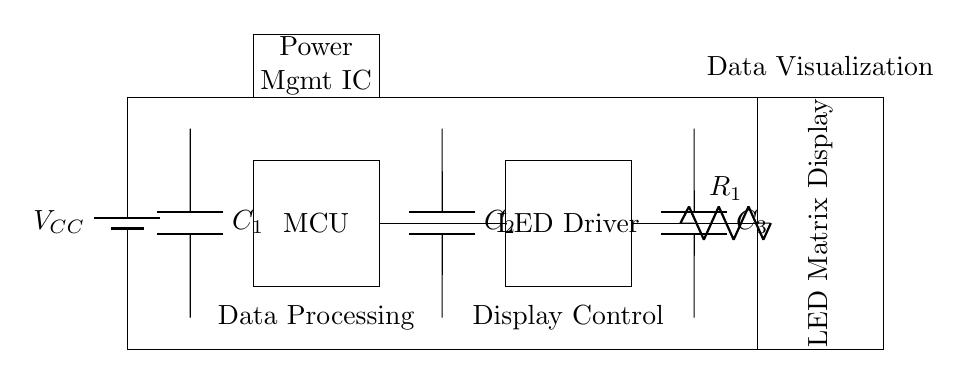What is the power supply component in this circuit? The power supply component is labeled as a battery, indicated by the 'V_CC' label, which provides the necessary voltage for the circuit operation.
Answer: Battery What is the role of the microcontroller in this circuit? The microcontroller, labeled as 'MCU', is responsible for data processing and controlling the overall operation of the circuit.
Answer: Data processing How many decoupling capacitors are present in this circuit? There are three decoupling capacitors indicated by the labels C1, C2, and C3 connected to different parts of the circuit.
Answer: Three What component limits the current to the LED matrix display? The current limiting resistor labeled as 'R_1' is responsible for controlling the current that flows to the LED matrix display, ensuring it operates within safe limits.
Answer: Resistor Why is a Power Management IC used in this circuit? The Power Management IC, labeled as 'Power Mgmt IC', regulates the power supplied to various components, helping to maintain efficiency and stability in a low power appliance like this LED display driver circuit.
Answer: Regulates power 